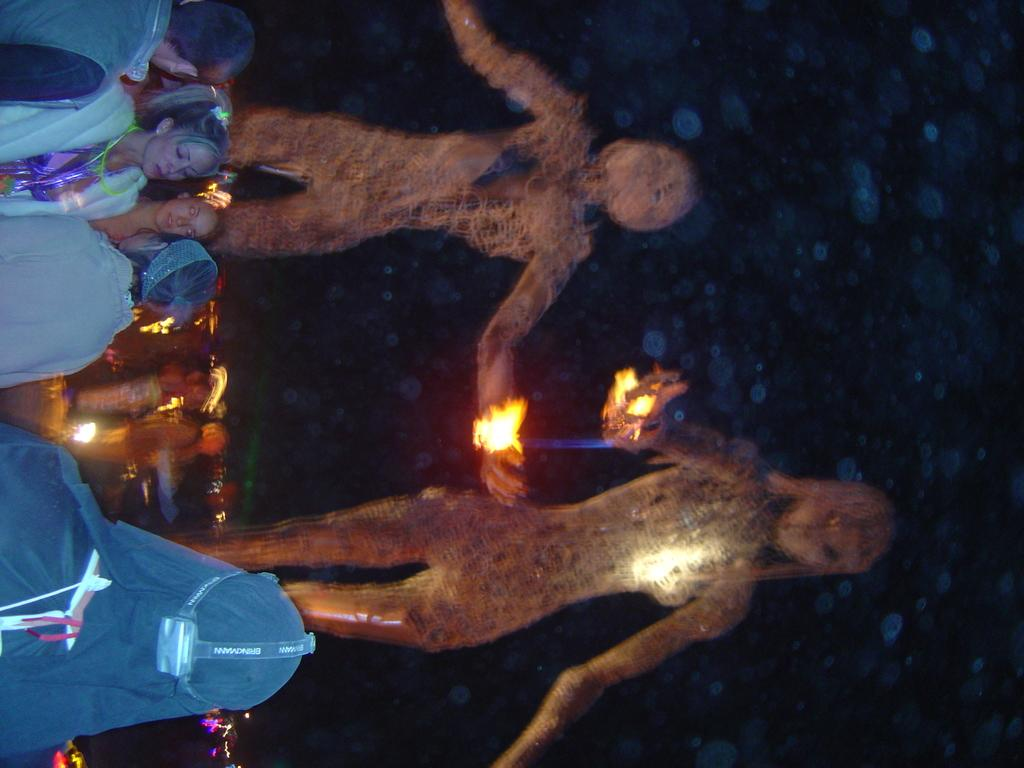What is located on the left side of the image? There are people on the left side of the image. What is behind the people in the image? There are statues behind the people. What is the condition of the statues in the image? The statues appear to be burning. What can be seen in the background of the image? There are lights visible in the background of the image. What type of banana can be seen floating in the sky in the image? There is no banana present in the image, and therefore no such activity can be observed. 